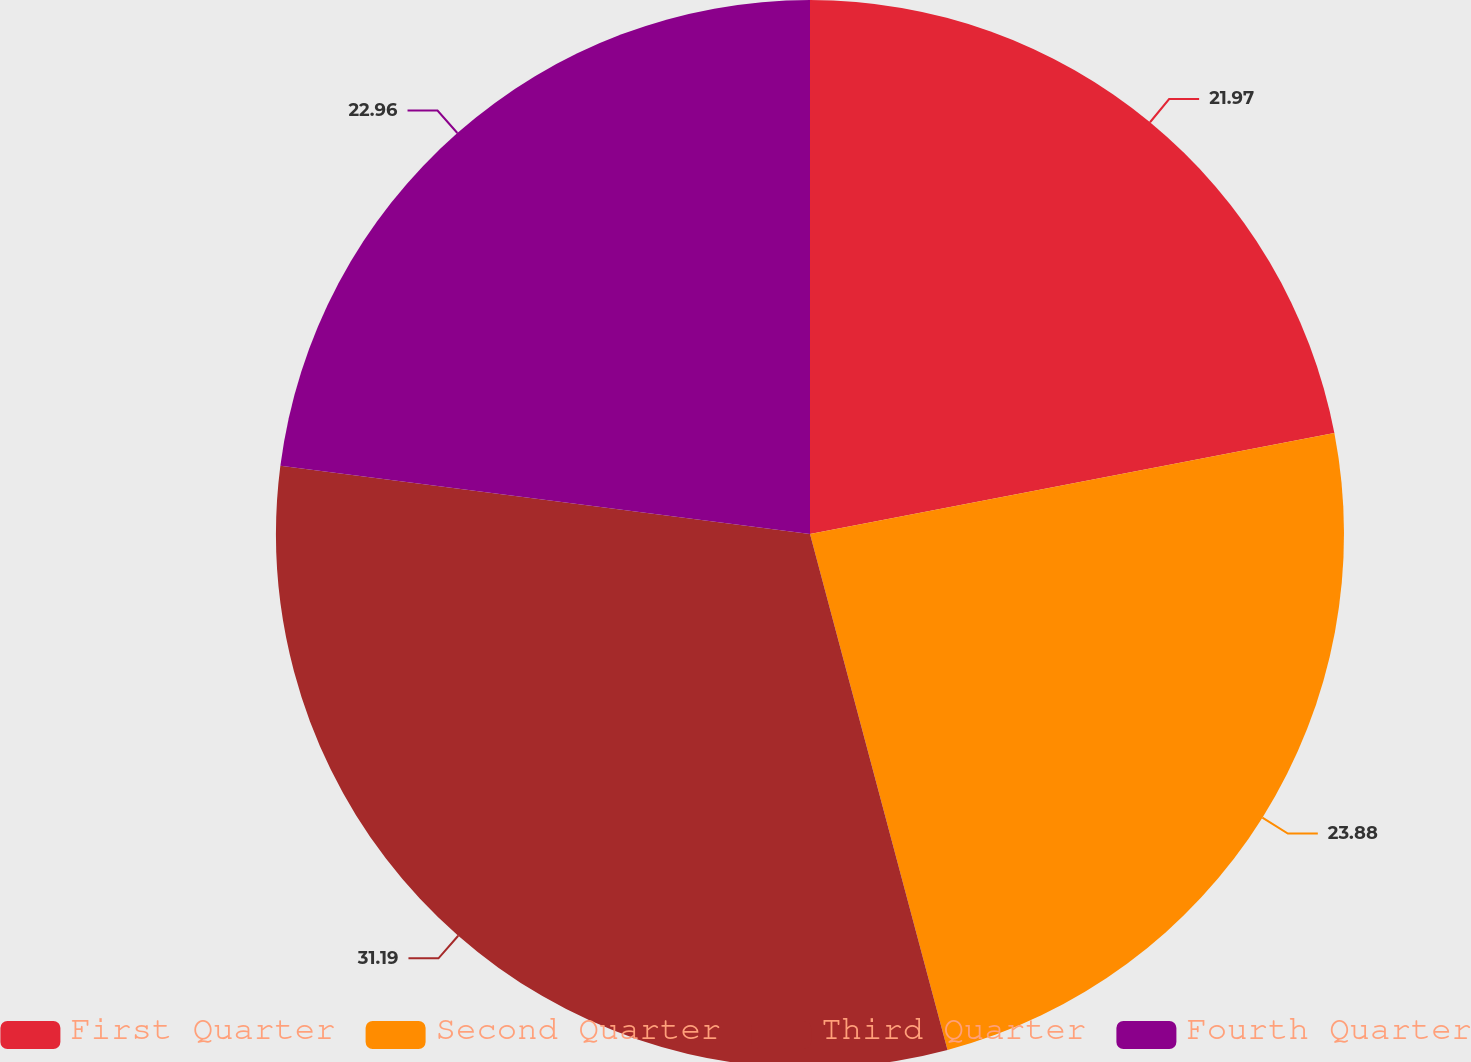<chart> <loc_0><loc_0><loc_500><loc_500><pie_chart><fcel>First Quarter<fcel>Second Quarter<fcel>Third Quarter<fcel>Fourth Quarter<nl><fcel>21.97%<fcel>23.88%<fcel>31.18%<fcel>22.96%<nl></chart> 